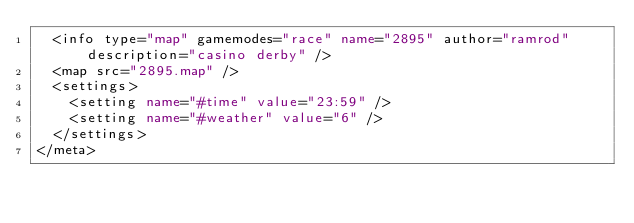Convert code to text. <code><loc_0><loc_0><loc_500><loc_500><_XML_>  <info type="map" gamemodes="race" name="2895" author="ramrod" description="casino derby" />
  <map src="2895.map" />
  <settings>
    <setting name="#time" value="23:59" />
    <setting name="#weather" value="6" />
  </settings>
</meta></code> 